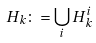<formula> <loc_0><loc_0><loc_500><loc_500>H _ { k } \colon = \bigcup _ { i } H ^ { i } _ { k }</formula> 